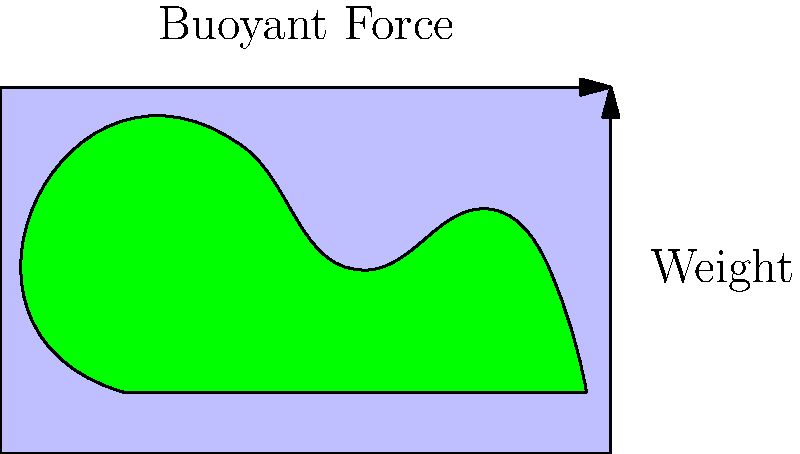A dinosaur-shaped toy is completely submerged in a bathtub filled with water. If the toy has a volume of 500 cm³ and the density of water is 1 g/cm³, what is the magnitude of the buoyant force acting on the toy? To solve this problem, we'll use Archimedes' principle and follow these steps:

1. Recall Archimedes' principle: The buoyant force on an object submerged in a fluid is equal to the weight of the fluid displaced by the object.

2. Calculate the mass of water displaced:
   Volume of toy = Volume of water displaced = 500 cm³
   Density of water = 1 g/cm³
   Mass of water displaced = Volume × Density
   $m = 500 \text{ cm³} \times 1 \text{ g/cm³} = 500 \text{ g} = 0.5 \text{ kg}$

3. Calculate the weight of the displaced water:
   Weight = mass × acceleration due to gravity
   $W = mg = 0.5 \text{ kg} \times 9.8 \text{ m/s²} = 4.9 \text{ N}$

4. According to Archimedes' principle, the buoyant force is equal to the weight of the displaced water:
   Buoyant Force = 4.9 N

Therefore, the magnitude of the buoyant force acting on the dinosaur-shaped toy is 4.9 N.
Answer: 4.9 N 